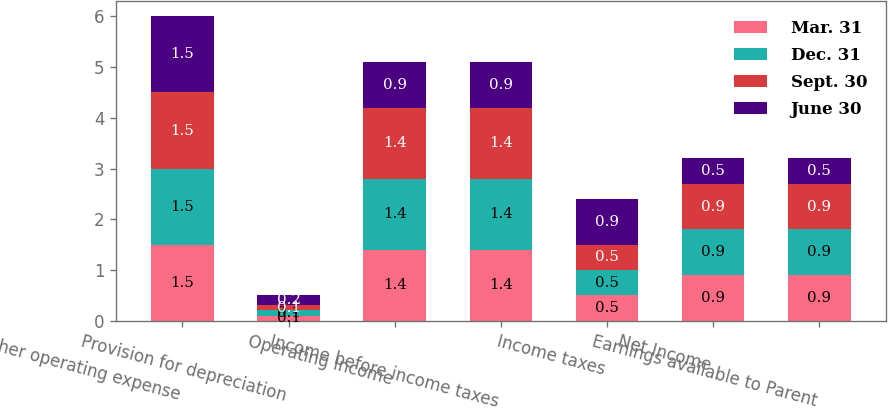Convert chart to OTSL. <chart><loc_0><loc_0><loc_500><loc_500><stacked_bar_chart><ecel><fcel>Other operating expense<fcel>Provision for depreciation<fcel>Operating Income<fcel>Income before income taxes<fcel>Income taxes<fcel>Net Income<fcel>Earnings available to Parent<nl><fcel>Mar. 31<fcel>1.5<fcel>0.1<fcel>1.4<fcel>1.4<fcel>0.5<fcel>0.9<fcel>0.9<nl><fcel>Dec. 31<fcel>1.5<fcel>0.1<fcel>1.4<fcel>1.4<fcel>0.5<fcel>0.9<fcel>0.9<nl><fcel>Sept. 30<fcel>1.5<fcel>0.1<fcel>1.4<fcel>1.4<fcel>0.5<fcel>0.9<fcel>0.9<nl><fcel>June 30<fcel>1.5<fcel>0.2<fcel>0.9<fcel>0.9<fcel>0.9<fcel>0.5<fcel>0.5<nl></chart> 